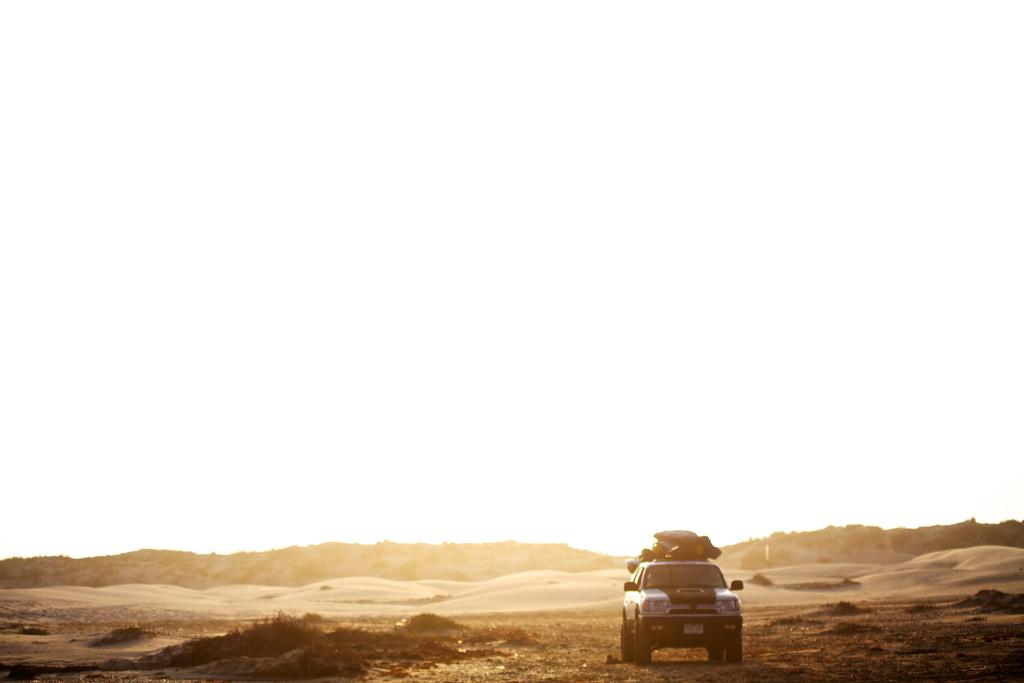What is located at the bottom of the image? There is a vehicle at the bottom of the image. What type of terrain is present at the bottom of the image? Sand, grass, and trees are present at the bottom of the image. What can be seen in the background of the image? There is sky visible in the background of the image. What type of pain is the vehicle experiencing in the image? There is no indication of pain in the image; it is a vehicle and not a living being. 